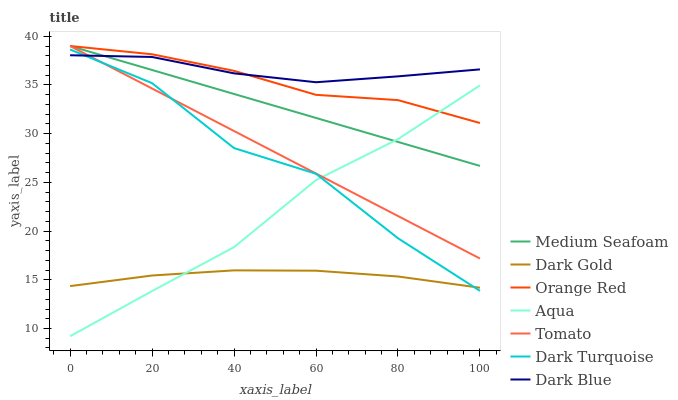Does Dark Gold have the minimum area under the curve?
Answer yes or no. Yes. Does Dark Blue have the maximum area under the curve?
Answer yes or no. Yes. Does Dark Turquoise have the minimum area under the curve?
Answer yes or no. No. Does Dark Turquoise have the maximum area under the curve?
Answer yes or no. No. Is Tomato the smoothest?
Answer yes or no. Yes. Is Dark Turquoise the roughest?
Answer yes or no. Yes. Is Dark Gold the smoothest?
Answer yes or no. No. Is Dark Gold the roughest?
Answer yes or no. No. Does Aqua have the lowest value?
Answer yes or no. Yes. Does Dark Gold have the lowest value?
Answer yes or no. No. Does Medium Seafoam have the highest value?
Answer yes or no. Yes. Does Dark Turquoise have the highest value?
Answer yes or no. No. Is Dark Turquoise less than Orange Red?
Answer yes or no. Yes. Is Tomato greater than Dark Gold?
Answer yes or no. Yes. Does Aqua intersect Medium Seafoam?
Answer yes or no. Yes. Is Aqua less than Medium Seafoam?
Answer yes or no. No. Is Aqua greater than Medium Seafoam?
Answer yes or no. No. Does Dark Turquoise intersect Orange Red?
Answer yes or no. No. 